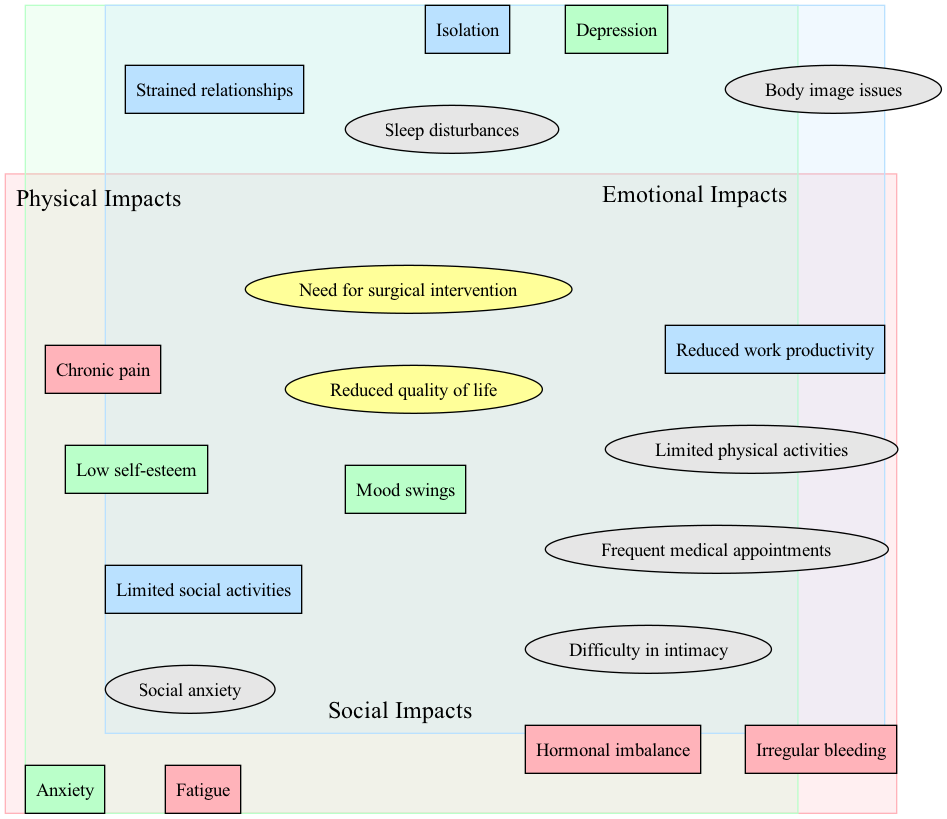What elements are included under "Physical Impacts"? The diagram lists several elements under the "Physical Impacts" circle. These are chronic pain, fatigue, irregular bleeding, and hormonal imbalance.
Answer: Chronic pain, fatigue, irregular bleeding, hormonal imbalance What is the central overlap in the diagram? The central overlap area of the Venn diagram includes two elements that are significant to all three impact categories. These elements are reduced quality of life and need for surgical intervention.
Answer: Reduced quality of life, need for surgical intervention How many elements are listed under "Emotional Impacts"? The "Emotional Impacts" circle contains four elements: anxiety, depression, mood swings, and low self-esteem. Counting these gives a total of four elements.
Answer: 4 Which overlaps exist between the circles? Upon examining the overlaps in the diagram, there are three identified overlaps between the circles: Physical-Emotional, Emotional-Social, and Physical-Social, in addition to the central overlap.
Answer: 4 What element is common between Physical and Emotional impacts? The overlap between the "Physical Impacts" and "Emotional Impacts" circles includes sleep disturbances and body image issues. Checking the overlaps will confirm sleep disturbances as a common element.
Answer: Sleep disturbances What are the emotional impacts that affect social interactions? The overlap between "Emotional Impacts" and "Social Impacts" highlights difficulties that affect social interactions. The emotions causing issues here are difficulty in intimacy and social anxiety.
Answer: Difficulty in intimacy, social anxiety How do physical impacts restrict social activities? The "Physical-Social" overlap indicates that there are specific physical impacts that affect social behavior, namely limited physical activities and frequent medical appointments, which hinder participation in social events.
Answer: Limited physical activities, frequent medical appointments How many total unique impacts are represented in the diagram? By reviewing each category and the overlaps, we find that the diagram lists various unique elements. If we total all unique elements from "Physical Impacts," "Emotional Impacts," "Social Impacts," and the overlaps, we find there are twelve unique impacts represented.
Answer: 12 